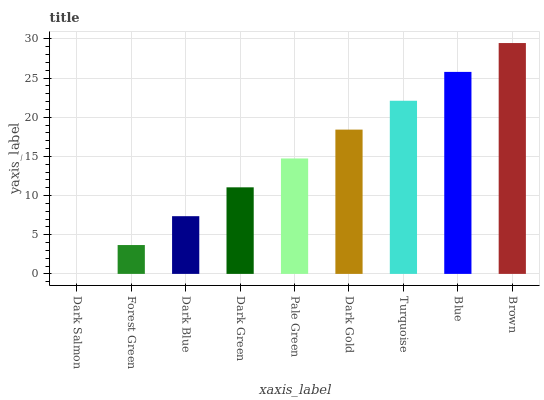Is Forest Green the minimum?
Answer yes or no. No. Is Forest Green the maximum?
Answer yes or no. No. Is Forest Green greater than Dark Salmon?
Answer yes or no. Yes. Is Dark Salmon less than Forest Green?
Answer yes or no. Yes. Is Dark Salmon greater than Forest Green?
Answer yes or no. No. Is Forest Green less than Dark Salmon?
Answer yes or no. No. Is Pale Green the high median?
Answer yes or no. Yes. Is Pale Green the low median?
Answer yes or no. Yes. Is Dark Gold the high median?
Answer yes or no. No. Is Forest Green the low median?
Answer yes or no. No. 